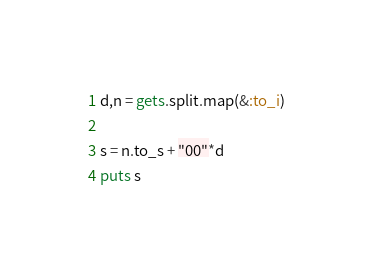Convert code to text. <code><loc_0><loc_0><loc_500><loc_500><_Ruby_>d,n = gets.split.map(&:to_i)

s = n.to_s + "00"*d
puts s</code> 